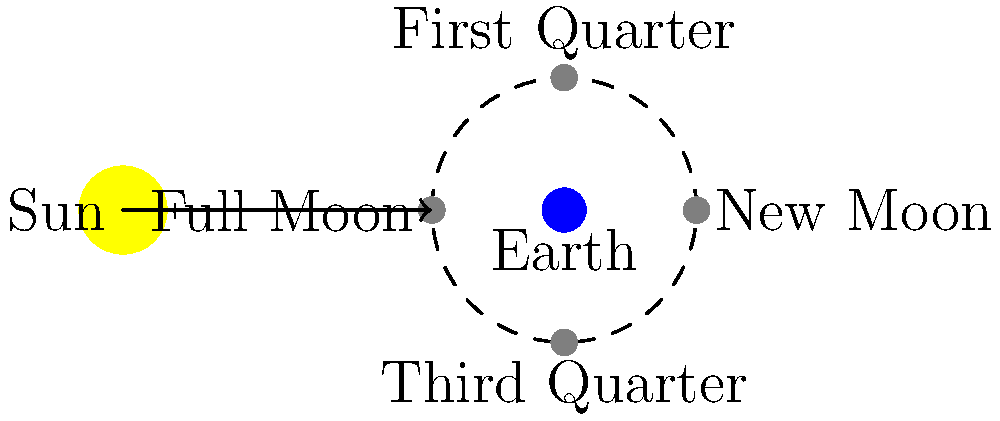In the context of privacy law and data protection, consider the phases of the Moon as an analogy for different levels of data visibility. If the Sun represents a data source and Earth represents a privacy regulator, which phase of the Moon would best represent a scenario where a company has partially disclosed sensitive information to the regulator? To answer this question, let's break down the analogy and the Moon's phases:

1. The Sun (data source) illuminates the Moon (company's data).
2. Earth (privacy regulator) observes the Moon's illuminated portion.
3. The Moon's phases represent different levels of data visibility:

   a. New Moon: The Moon is between Earth and Sun, showing no illuminated surface to Earth. This represents complete data concealment.
   
   b. First Quarter: Half of the Moon's visible surface is illuminated. This represents partial data disclosure.
   
   c. Full Moon: The entire visible surface of the Moon is illuminated. This represents complete data disclosure.
   
   d. Third Quarter: Again, half of the Moon's visible surface is illuminated, but on the opposite side compared to the First Quarter.

4. In the scenario where a company has partially disclosed sensitive information to the regulator, we're looking for a phase that shows partial illumination.

5. The First Quarter or Third Quarter phases both show half of the Moon's visible surface illuminated, representing partial disclosure of information.

Given the context of privacy law and partial disclosure of sensitive information, the First Quarter or Third Quarter Moon phases best represent this scenario.
Answer: First Quarter or Third Quarter 